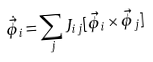<formula> <loc_0><loc_0><loc_500><loc_500>\dot { \vec { \phi } } _ { i } = \sum _ { j } J _ { i j } [ \vec { \phi } _ { i } \times \vec { \phi } _ { j } ]</formula> 